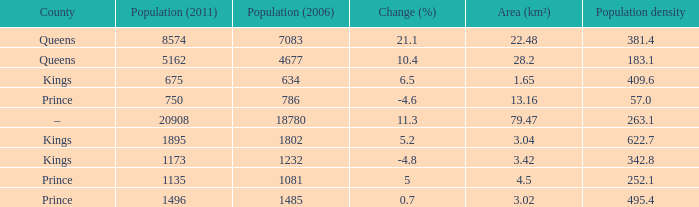What was the Area (km²) when the Population (2011) was 8574, and the Population density was larger than 381.4? None. 